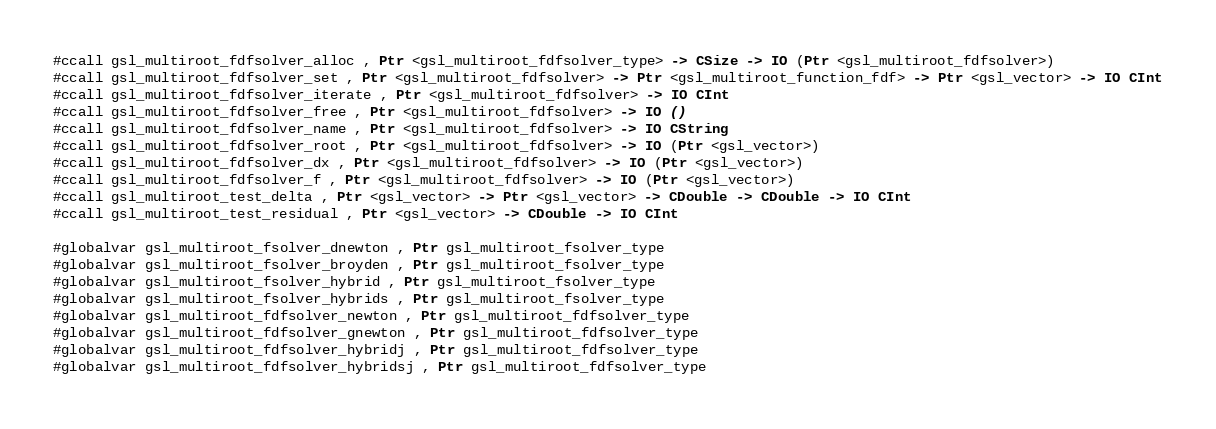<code> <loc_0><loc_0><loc_500><loc_500><_Haskell_>
#ccall gsl_multiroot_fdfsolver_alloc , Ptr <gsl_multiroot_fdfsolver_type> -> CSize -> IO (Ptr <gsl_multiroot_fdfsolver>)
#ccall gsl_multiroot_fdfsolver_set , Ptr <gsl_multiroot_fdfsolver> -> Ptr <gsl_multiroot_function_fdf> -> Ptr <gsl_vector> -> IO CInt
#ccall gsl_multiroot_fdfsolver_iterate , Ptr <gsl_multiroot_fdfsolver> -> IO CInt
#ccall gsl_multiroot_fdfsolver_free , Ptr <gsl_multiroot_fdfsolver> -> IO ()
#ccall gsl_multiroot_fdfsolver_name , Ptr <gsl_multiroot_fdfsolver> -> IO CString 
#ccall gsl_multiroot_fdfsolver_root , Ptr <gsl_multiroot_fdfsolver> -> IO (Ptr <gsl_vector>)
#ccall gsl_multiroot_fdfsolver_dx , Ptr <gsl_multiroot_fdfsolver> -> IO (Ptr <gsl_vector>)
#ccall gsl_multiroot_fdfsolver_f , Ptr <gsl_multiroot_fdfsolver> -> IO (Ptr <gsl_vector>)
#ccall gsl_multiroot_test_delta , Ptr <gsl_vector> -> Ptr <gsl_vector> -> CDouble -> CDouble -> IO CInt
#ccall gsl_multiroot_test_residual , Ptr <gsl_vector> -> CDouble -> IO CInt

#globalvar gsl_multiroot_fsolver_dnewton , Ptr gsl_multiroot_fsolver_type
#globalvar gsl_multiroot_fsolver_broyden , Ptr gsl_multiroot_fsolver_type
#globalvar gsl_multiroot_fsolver_hybrid , Ptr gsl_multiroot_fsolver_type
#globalvar gsl_multiroot_fsolver_hybrids , Ptr gsl_multiroot_fsolver_type
#globalvar gsl_multiroot_fdfsolver_newton , Ptr gsl_multiroot_fdfsolver_type
#globalvar gsl_multiroot_fdfsolver_gnewton , Ptr gsl_multiroot_fdfsolver_type
#globalvar gsl_multiroot_fdfsolver_hybridj , Ptr gsl_multiroot_fdfsolver_type
#globalvar gsl_multiroot_fdfsolver_hybridsj , Ptr gsl_multiroot_fdfsolver_type

</code> 